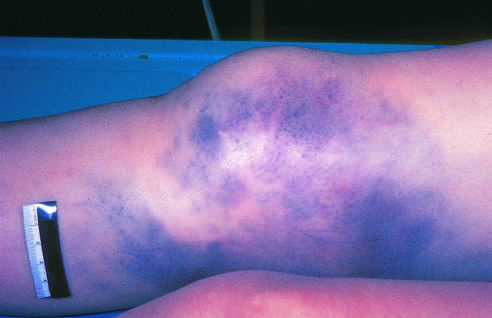s the skin intact?
Answer the question using a single word or phrase. Yes 